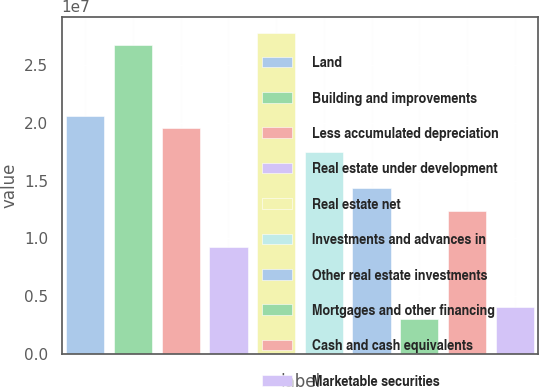Convert chart to OTSL. <chart><loc_0><loc_0><loc_500><loc_500><bar_chart><fcel>Land<fcel>Building and improvements<fcel>Less accumulated depreciation<fcel>Real estate under development<fcel>Real estate net<fcel>Investments and advances in<fcel>Other real estate investments<fcel>Mortgages and other financing<fcel>Cash and cash equivalents<fcel>Marketable securities<nl><fcel>2.05714e+07<fcel>2.67427e+07<fcel>1.95428e+07<fcel>9.25717e+06<fcel>2.77713e+07<fcel>1.74857e+07<fcel>1.44e+07<fcel>3.08579e+06<fcel>1.23429e+07<fcel>4.11435e+06<nl></chart> 